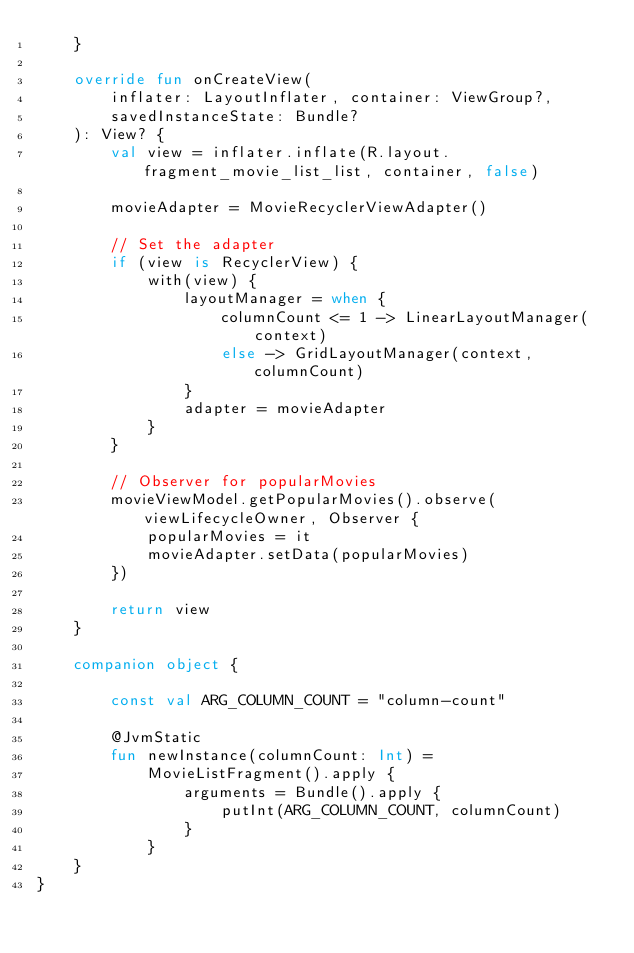Convert code to text. <code><loc_0><loc_0><loc_500><loc_500><_Kotlin_>    }

    override fun onCreateView(
        inflater: LayoutInflater, container: ViewGroup?,
        savedInstanceState: Bundle?
    ): View? {
        val view = inflater.inflate(R.layout.fragment_movie_list_list, container, false)

        movieAdapter = MovieRecyclerViewAdapter()

        // Set the adapter
        if (view is RecyclerView) {
            with(view) {
                layoutManager = when {
                    columnCount <= 1 -> LinearLayoutManager(context)
                    else -> GridLayoutManager(context, columnCount)
                }
                adapter = movieAdapter
            }
        }

        // Observer for popularMovies
        movieViewModel.getPopularMovies().observe(viewLifecycleOwner, Observer {
            popularMovies = it
            movieAdapter.setData(popularMovies)
        })

        return view
    }

    companion object {

        const val ARG_COLUMN_COUNT = "column-count"

        @JvmStatic
        fun newInstance(columnCount: Int) =
            MovieListFragment().apply {
                arguments = Bundle().apply {
                    putInt(ARG_COLUMN_COUNT, columnCount)
                }
            }
    }
}
</code> 